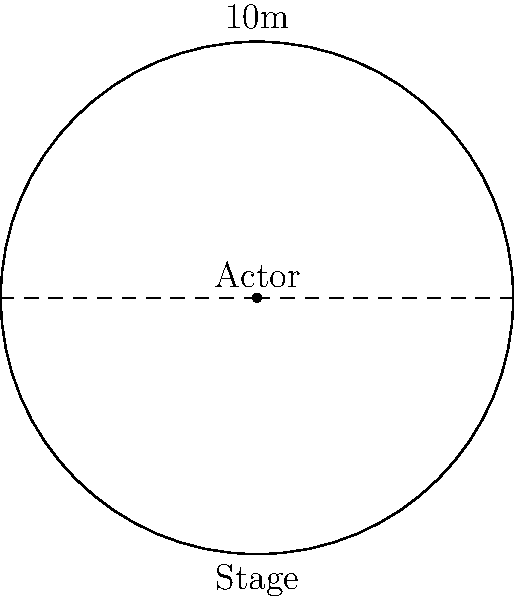A circular stage has a diameter of 10 meters. An actor stands at the center of the stage and can project their voice to cover an area of 75% of the total stage area. What is the radius of the circular area covered by the actor's voice projection? Let's approach this step-by-step:

1) First, we need to calculate the area of the entire stage:
   Radius of stage = 10m / 2 = 5m
   Area of stage = $\pi r^2 = \pi (5)^2 = 25\pi$ sq meters

2) The actor's voice covers 75% of this area:
   Area covered = 75% of $25\pi$ = $0.75 \times 25\pi = 18.75\pi$ sq meters

3) Now, we need to find the radius of this covered area. Let's call it $x$.
   Area covered = $\pi x^2 = 18.75\pi$

4) Dividing both sides by $\pi$:
   $x^2 = 18.75$

5) Taking the square root of both sides:
   $x = \sqrt{18.75} = \sqrt{75/4} = \frac{\sqrt{75}}{2} = \frac{5\sqrt{3}}{2}$

Therefore, the radius of the area covered by the actor's voice is $\frac{5\sqrt{3}}{2}$ meters.
Answer: $\frac{5\sqrt{3}}{2}$ meters 